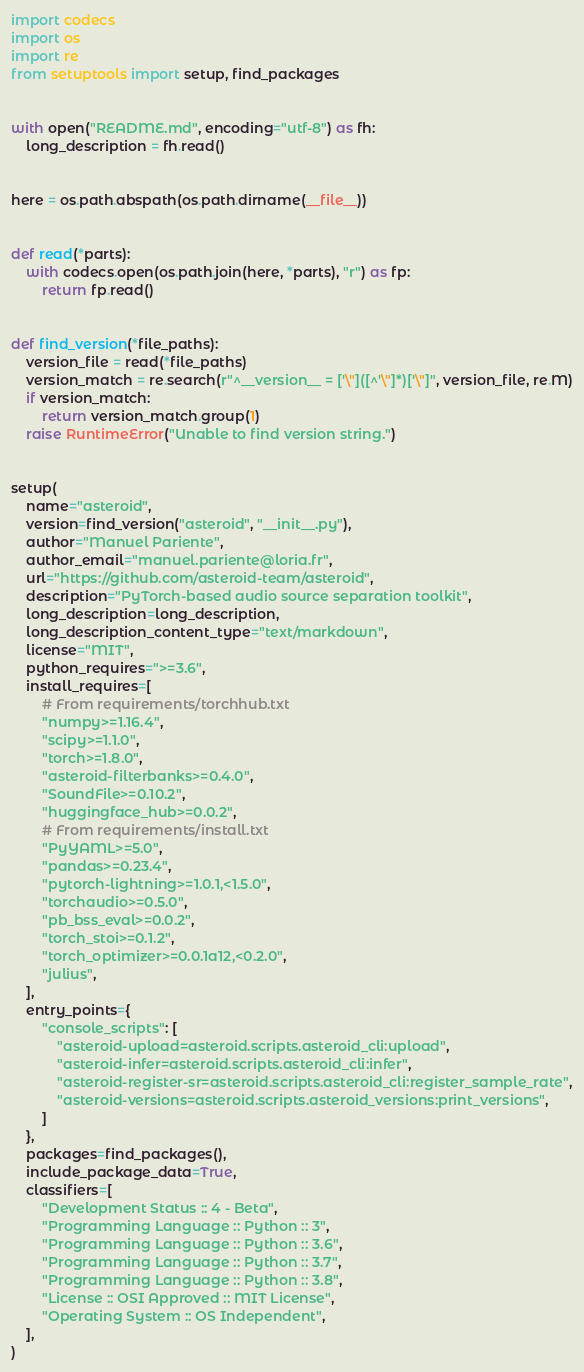<code> <loc_0><loc_0><loc_500><loc_500><_Python_>import codecs
import os
import re
from setuptools import setup, find_packages


with open("README.md", encoding="utf-8") as fh:
    long_description = fh.read()


here = os.path.abspath(os.path.dirname(__file__))


def read(*parts):
    with codecs.open(os.path.join(here, *parts), "r") as fp:
        return fp.read()


def find_version(*file_paths):
    version_file = read(*file_paths)
    version_match = re.search(r"^__version__ = ['\"]([^'\"]*)['\"]", version_file, re.M)
    if version_match:
        return version_match.group(1)
    raise RuntimeError("Unable to find version string.")


setup(
    name="asteroid",
    version=find_version("asteroid", "__init__.py"),
    author="Manuel Pariente",
    author_email="manuel.pariente@loria.fr",
    url="https://github.com/asteroid-team/asteroid",
    description="PyTorch-based audio source separation toolkit",
    long_description=long_description,
    long_description_content_type="text/markdown",
    license="MIT",
    python_requires=">=3.6",
    install_requires=[
        # From requirements/torchhub.txt
        "numpy>=1.16.4",
        "scipy>=1.1.0",
        "torch>=1.8.0",
        "asteroid-filterbanks>=0.4.0",
        "SoundFile>=0.10.2",
        "huggingface_hub>=0.0.2",
        # From requirements/install.txt
        "PyYAML>=5.0",
        "pandas>=0.23.4",
        "pytorch-lightning>=1.0.1,<1.5.0",
        "torchaudio>=0.5.0",
        "pb_bss_eval>=0.0.2",
        "torch_stoi>=0.1.2",
        "torch_optimizer>=0.0.1a12,<0.2.0",
        "julius",
    ],
    entry_points={
        "console_scripts": [
            "asteroid-upload=asteroid.scripts.asteroid_cli:upload",
            "asteroid-infer=asteroid.scripts.asteroid_cli:infer",
            "asteroid-register-sr=asteroid.scripts.asteroid_cli:register_sample_rate",
            "asteroid-versions=asteroid.scripts.asteroid_versions:print_versions",
        ]
    },
    packages=find_packages(),
    include_package_data=True,
    classifiers=[
        "Development Status :: 4 - Beta",
        "Programming Language :: Python :: 3",
        "Programming Language :: Python :: 3.6",
        "Programming Language :: Python :: 3.7",
        "Programming Language :: Python :: 3.8",
        "License :: OSI Approved :: MIT License",
        "Operating System :: OS Independent",
    ],
)
</code> 